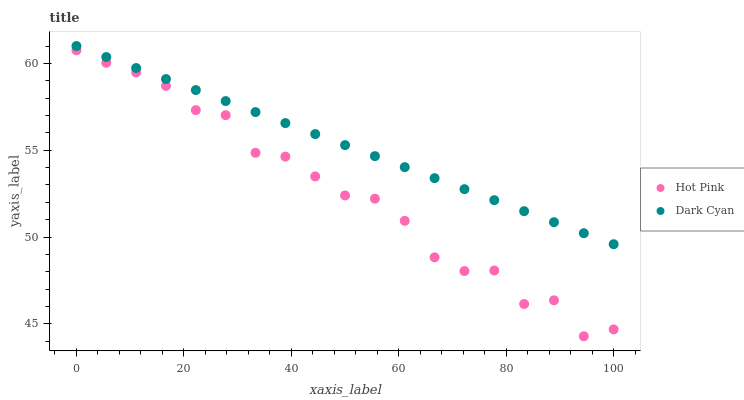Does Hot Pink have the minimum area under the curve?
Answer yes or no. Yes. Does Dark Cyan have the maximum area under the curve?
Answer yes or no. Yes. Does Hot Pink have the maximum area under the curve?
Answer yes or no. No. Is Dark Cyan the smoothest?
Answer yes or no. Yes. Is Hot Pink the roughest?
Answer yes or no. Yes. Is Hot Pink the smoothest?
Answer yes or no. No. Does Hot Pink have the lowest value?
Answer yes or no. Yes. Does Dark Cyan have the highest value?
Answer yes or no. Yes. Does Hot Pink have the highest value?
Answer yes or no. No. Is Hot Pink less than Dark Cyan?
Answer yes or no. Yes. Is Dark Cyan greater than Hot Pink?
Answer yes or no. Yes. Does Hot Pink intersect Dark Cyan?
Answer yes or no. No. 